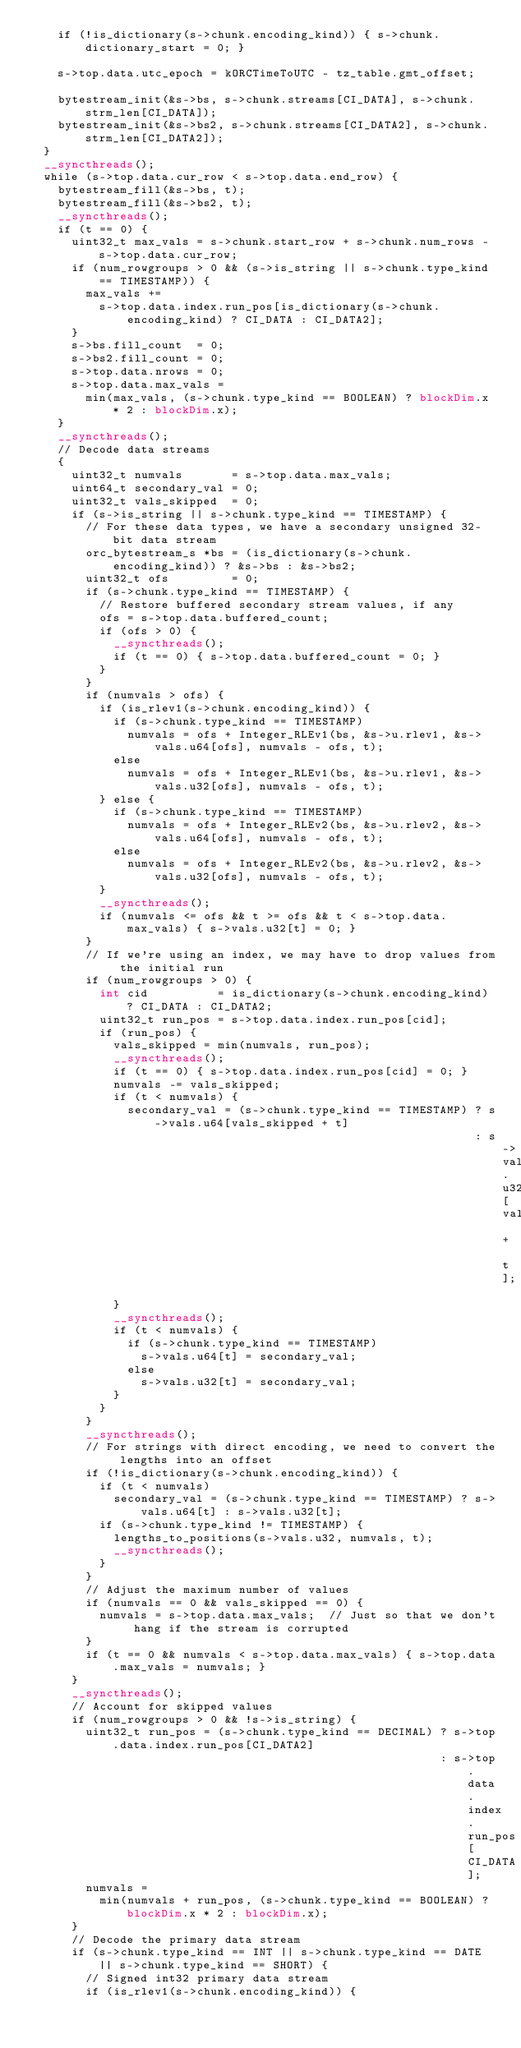<code> <loc_0><loc_0><loc_500><loc_500><_Cuda_>    if (!is_dictionary(s->chunk.encoding_kind)) { s->chunk.dictionary_start = 0; }

    s->top.data.utc_epoch = kORCTimeToUTC - tz_table.gmt_offset;

    bytestream_init(&s->bs, s->chunk.streams[CI_DATA], s->chunk.strm_len[CI_DATA]);
    bytestream_init(&s->bs2, s->chunk.streams[CI_DATA2], s->chunk.strm_len[CI_DATA2]);
  }
  __syncthreads();
  while (s->top.data.cur_row < s->top.data.end_row) {
    bytestream_fill(&s->bs, t);
    bytestream_fill(&s->bs2, t);
    __syncthreads();
    if (t == 0) {
      uint32_t max_vals = s->chunk.start_row + s->chunk.num_rows - s->top.data.cur_row;
      if (num_rowgroups > 0 && (s->is_string || s->chunk.type_kind == TIMESTAMP)) {
        max_vals +=
          s->top.data.index.run_pos[is_dictionary(s->chunk.encoding_kind) ? CI_DATA : CI_DATA2];
      }
      s->bs.fill_count  = 0;
      s->bs2.fill_count = 0;
      s->top.data.nrows = 0;
      s->top.data.max_vals =
        min(max_vals, (s->chunk.type_kind == BOOLEAN) ? blockDim.x * 2 : blockDim.x);
    }
    __syncthreads();
    // Decode data streams
    {
      uint32_t numvals       = s->top.data.max_vals;
      uint64_t secondary_val = 0;
      uint32_t vals_skipped  = 0;
      if (s->is_string || s->chunk.type_kind == TIMESTAMP) {
        // For these data types, we have a secondary unsigned 32-bit data stream
        orc_bytestream_s *bs = (is_dictionary(s->chunk.encoding_kind)) ? &s->bs : &s->bs2;
        uint32_t ofs         = 0;
        if (s->chunk.type_kind == TIMESTAMP) {
          // Restore buffered secondary stream values, if any
          ofs = s->top.data.buffered_count;
          if (ofs > 0) {
            __syncthreads();
            if (t == 0) { s->top.data.buffered_count = 0; }
          }
        }
        if (numvals > ofs) {
          if (is_rlev1(s->chunk.encoding_kind)) {
            if (s->chunk.type_kind == TIMESTAMP)
              numvals = ofs + Integer_RLEv1(bs, &s->u.rlev1, &s->vals.u64[ofs], numvals - ofs, t);
            else
              numvals = ofs + Integer_RLEv1(bs, &s->u.rlev1, &s->vals.u32[ofs], numvals - ofs, t);
          } else {
            if (s->chunk.type_kind == TIMESTAMP)
              numvals = ofs + Integer_RLEv2(bs, &s->u.rlev2, &s->vals.u64[ofs], numvals - ofs, t);
            else
              numvals = ofs + Integer_RLEv2(bs, &s->u.rlev2, &s->vals.u32[ofs], numvals - ofs, t);
          }
          __syncthreads();
          if (numvals <= ofs && t >= ofs && t < s->top.data.max_vals) { s->vals.u32[t] = 0; }
        }
        // If we're using an index, we may have to drop values from the initial run
        if (num_rowgroups > 0) {
          int cid          = is_dictionary(s->chunk.encoding_kind) ? CI_DATA : CI_DATA2;
          uint32_t run_pos = s->top.data.index.run_pos[cid];
          if (run_pos) {
            vals_skipped = min(numvals, run_pos);
            __syncthreads();
            if (t == 0) { s->top.data.index.run_pos[cid] = 0; }
            numvals -= vals_skipped;
            if (t < numvals) {
              secondary_val = (s->chunk.type_kind == TIMESTAMP) ? s->vals.u64[vals_skipped + t]
                                                                : s->vals.u32[vals_skipped + t];
            }
            __syncthreads();
            if (t < numvals) {
              if (s->chunk.type_kind == TIMESTAMP)
                s->vals.u64[t] = secondary_val;
              else
                s->vals.u32[t] = secondary_val;
            }
          }
        }
        __syncthreads();
        // For strings with direct encoding, we need to convert the lengths into an offset
        if (!is_dictionary(s->chunk.encoding_kind)) {
          if (t < numvals)
            secondary_val = (s->chunk.type_kind == TIMESTAMP) ? s->vals.u64[t] : s->vals.u32[t];
          if (s->chunk.type_kind != TIMESTAMP) {
            lengths_to_positions(s->vals.u32, numvals, t);
            __syncthreads();
          }
        }
        // Adjust the maximum number of values
        if (numvals == 0 && vals_skipped == 0) {
          numvals = s->top.data.max_vals;  // Just so that we don't hang if the stream is corrupted
        }
        if (t == 0 && numvals < s->top.data.max_vals) { s->top.data.max_vals = numvals; }
      }
      __syncthreads();
      // Account for skipped values
      if (num_rowgroups > 0 && !s->is_string) {
        uint32_t run_pos = (s->chunk.type_kind == DECIMAL) ? s->top.data.index.run_pos[CI_DATA2]
                                                           : s->top.data.index.run_pos[CI_DATA];
        numvals =
          min(numvals + run_pos, (s->chunk.type_kind == BOOLEAN) ? blockDim.x * 2 : blockDim.x);
      }
      // Decode the primary data stream
      if (s->chunk.type_kind == INT || s->chunk.type_kind == DATE || s->chunk.type_kind == SHORT) {
        // Signed int32 primary data stream
        if (is_rlev1(s->chunk.encoding_kind)) {</code> 